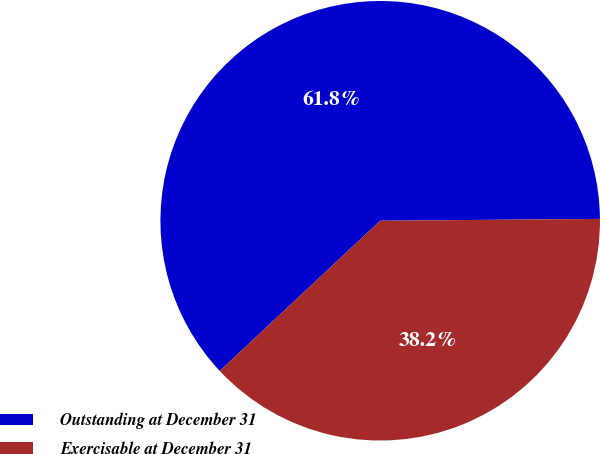Convert chart to OTSL. <chart><loc_0><loc_0><loc_500><loc_500><pie_chart><fcel>Outstanding at December 31<fcel>Exercisable at December 31<nl><fcel>61.84%<fcel>38.16%<nl></chart> 